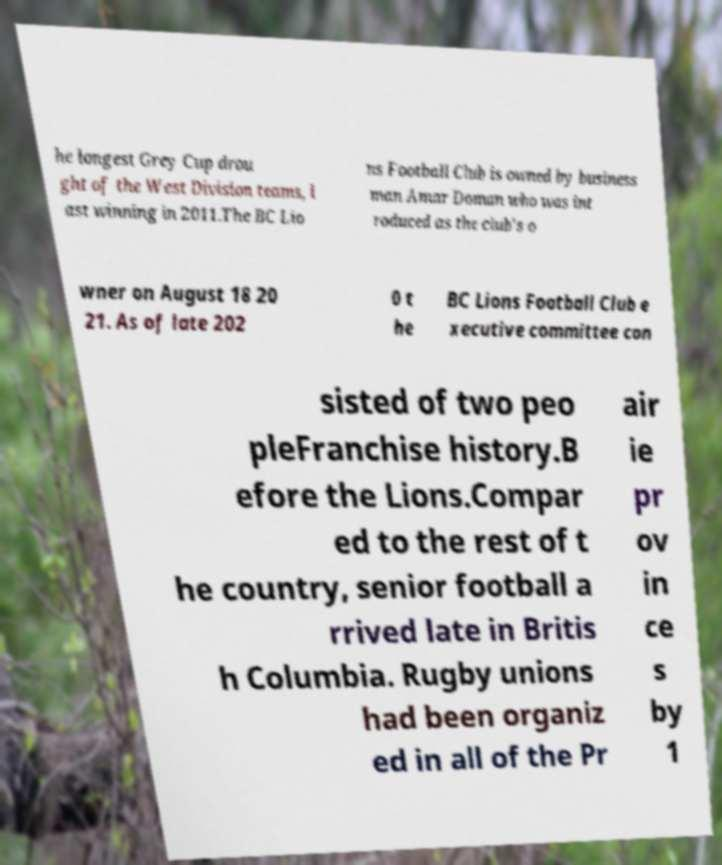Can you read and provide the text displayed in the image?This photo seems to have some interesting text. Can you extract and type it out for me? he longest Grey Cup drou ght of the West Division teams, l ast winning in 2011.The BC Lio ns Football Club is owned by business man Amar Doman who was int roduced as the club's o wner on August 18 20 21. As of late 202 0 t he BC Lions Football Club e xecutive committee con sisted of two peo pleFranchise history.B efore the Lions.Compar ed to the rest of t he country, senior football a rrived late in Britis h Columbia. Rugby unions had been organiz ed in all of the Pr air ie pr ov in ce s by 1 